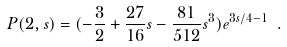Convert formula to latex. <formula><loc_0><loc_0><loc_500><loc_500>P ( 2 , s ) = ( - \frac { 3 } { 2 } + \frac { 2 7 } { 1 6 } s - \frac { 8 1 } { 5 1 2 } s ^ { 3 } ) e ^ { 3 s / 4 - 1 } \ .</formula> 